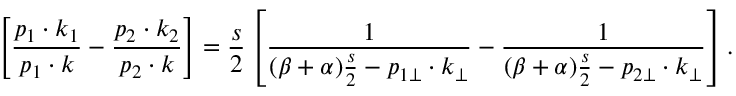<formula> <loc_0><loc_0><loc_500><loc_500>\left [ \frac { p _ { 1 } \cdot k _ { 1 } } { p _ { 1 } \cdot k } - \frac { p _ { 2 } \cdot k _ { 2 } } { p _ { 2 } \cdot k } \right ] = \frac { s } { 2 } \left [ \frac { 1 } { ( \beta + \alpha ) \frac { s } { 2 } - p _ { 1 \bot } \cdot k _ { \bot } } - \frac { 1 } { ( \beta + \alpha ) \frac { s } { 2 } - p _ { 2 \bot } \cdot k _ { \bot } } \right ] .</formula> 